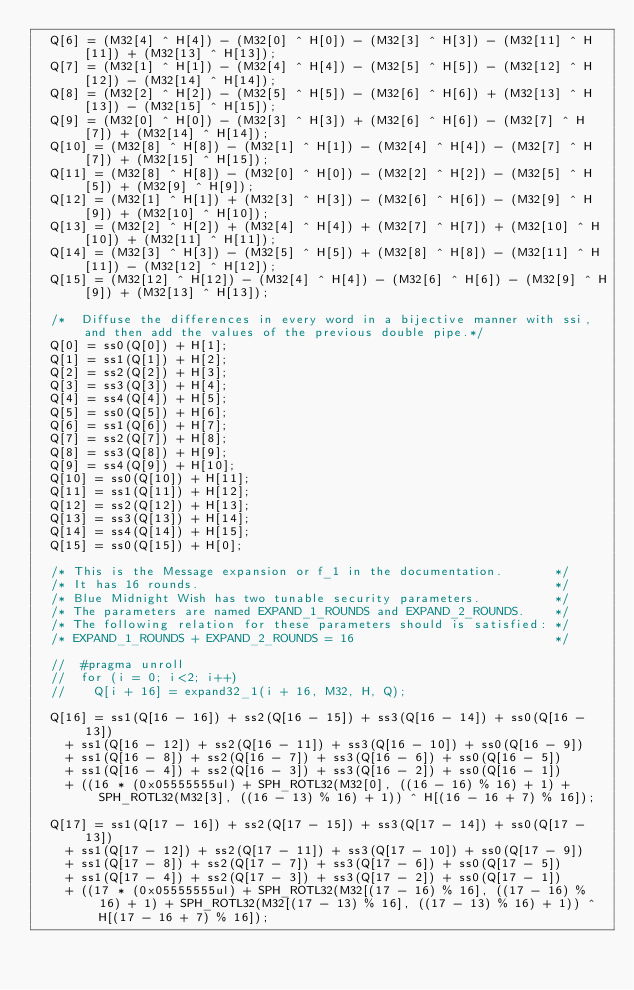Convert code to text. <code><loc_0><loc_0><loc_500><loc_500><_Cuda_>	Q[6] = (M32[4] ^ H[4]) - (M32[0] ^ H[0]) - (M32[3] ^ H[3]) - (M32[11] ^ H[11]) + (M32[13] ^ H[13]);
	Q[7] = (M32[1] ^ H[1]) - (M32[4] ^ H[4]) - (M32[5] ^ H[5]) - (M32[12] ^ H[12]) - (M32[14] ^ H[14]);
	Q[8] = (M32[2] ^ H[2]) - (M32[5] ^ H[5]) - (M32[6] ^ H[6]) + (M32[13] ^ H[13]) - (M32[15] ^ H[15]);
	Q[9] = (M32[0] ^ H[0]) - (M32[3] ^ H[3]) + (M32[6] ^ H[6]) - (M32[7] ^ H[7]) + (M32[14] ^ H[14]);
	Q[10] = (M32[8] ^ H[8]) - (M32[1] ^ H[1]) - (M32[4] ^ H[4]) - (M32[7] ^ H[7]) + (M32[15] ^ H[15]);
	Q[11] = (M32[8] ^ H[8]) - (M32[0] ^ H[0]) - (M32[2] ^ H[2]) - (M32[5] ^ H[5]) + (M32[9] ^ H[9]);
	Q[12] = (M32[1] ^ H[1]) + (M32[3] ^ H[3]) - (M32[6] ^ H[6]) - (M32[9] ^ H[9]) + (M32[10] ^ H[10]);
	Q[13] = (M32[2] ^ H[2]) + (M32[4] ^ H[4]) + (M32[7] ^ H[7]) + (M32[10] ^ H[10]) + (M32[11] ^ H[11]);
	Q[14] = (M32[3] ^ H[3]) - (M32[5] ^ H[5]) + (M32[8] ^ H[8]) - (M32[11] ^ H[11]) - (M32[12] ^ H[12]);
	Q[15] = (M32[12] ^ H[12]) - (M32[4] ^ H[4]) - (M32[6] ^ H[6]) - (M32[9] ^ H[9]) + (M32[13] ^ H[13]);

	/*  Diffuse the differences in every word in a bijective manner with ssi, and then add the values of the previous double pipe.*/
	Q[0] = ss0(Q[0]) + H[1];
	Q[1] = ss1(Q[1]) + H[2];
	Q[2] = ss2(Q[2]) + H[3];
	Q[3] = ss3(Q[3]) + H[4];
	Q[4] = ss4(Q[4]) + H[5];
	Q[5] = ss0(Q[5]) + H[6];
	Q[6] = ss1(Q[6]) + H[7];
	Q[7] = ss2(Q[7]) + H[8];
	Q[8] = ss3(Q[8]) + H[9];
	Q[9] = ss4(Q[9]) + H[10];
	Q[10] = ss0(Q[10]) + H[11];
	Q[11] = ss1(Q[11]) + H[12];
	Q[12] = ss2(Q[12]) + H[13];
	Q[13] = ss3(Q[13]) + H[14];
	Q[14] = ss4(Q[14]) + H[15];
	Q[15] = ss0(Q[15]) + H[0];

	/* This is the Message expansion or f_1 in the documentation.       */
	/* It has 16 rounds.                                                */
	/* Blue Midnight Wish has two tunable security parameters.          */
	/* The parameters are named EXPAND_1_ROUNDS and EXPAND_2_ROUNDS.    */
	/* The following relation for these parameters should is satisfied: */
	/* EXPAND_1_ROUNDS + EXPAND_2_ROUNDS = 16                           */

	//	#pragma unroll
	//	for (i = 0; i<2; i++)
	//		Q[i + 16] = expand32_1(i + 16, M32, H, Q);

	Q[16] = ss1(Q[16 - 16]) + ss2(Q[16 - 15]) + ss3(Q[16 - 14]) + ss0(Q[16 - 13])
		+ ss1(Q[16 - 12]) + ss2(Q[16 - 11]) + ss3(Q[16 - 10]) + ss0(Q[16 - 9])
		+ ss1(Q[16 - 8]) + ss2(Q[16 - 7]) + ss3(Q[16 - 6]) + ss0(Q[16 - 5])
		+ ss1(Q[16 - 4]) + ss2(Q[16 - 3]) + ss3(Q[16 - 2]) + ss0(Q[16 - 1])
		+ ((16 * (0x05555555ul) + SPH_ROTL32(M32[0], ((16 - 16) % 16) + 1) + SPH_ROTL32(M32[3], ((16 - 13) % 16) + 1)) ^ H[(16 - 16 + 7) % 16]);

	Q[17] = ss1(Q[17 - 16]) + ss2(Q[17 - 15]) + ss3(Q[17 - 14]) + ss0(Q[17 - 13])
		+ ss1(Q[17 - 12]) + ss2(Q[17 - 11]) + ss3(Q[17 - 10]) + ss0(Q[17 - 9])
		+ ss1(Q[17 - 8]) + ss2(Q[17 - 7]) + ss3(Q[17 - 6]) + ss0(Q[17 - 5])
		+ ss1(Q[17 - 4]) + ss2(Q[17 - 3]) + ss3(Q[17 - 2]) + ss0(Q[17 - 1])
		+ ((17 * (0x05555555ul) + SPH_ROTL32(M32[(17 - 16) % 16], ((17 - 16) % 16) + 1) + SPH_ROTL32(M32[(17 - 13) % 16], ((17 - 13) % 16) + 1)) ^ H[(17 - 16 + 7) % 16]);

</code> 